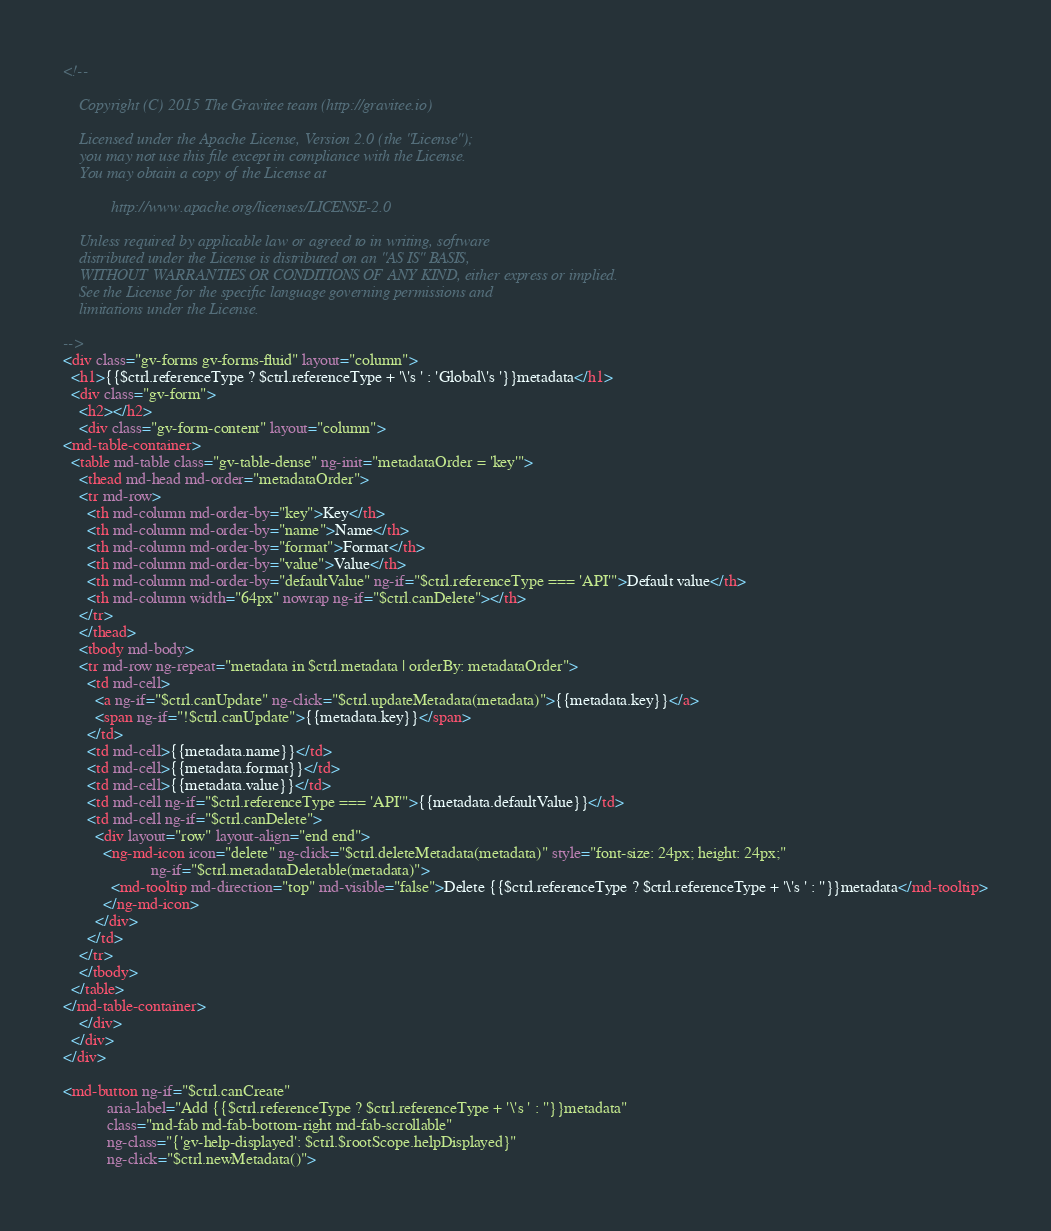<code> <loc_0><loc_0><loc_500><loc_500><_HTML_><!--

    Copyright (C) 2015 The Gravitee team (http://gravitee.io)

    Licensed under the Apache License, Version 2.0 (the "License");
    you may not use this file except in compliance with the License.
    You may obtain a copy of the License at

            http://www.apache.org/licenses/LICENSE-2.0

    Unless required by applicable law or agreed to in writing, software
    distributed under the License is distributed on an "AS IS" BASIS,
    WITHOUT WARRANTIES OR CONDITIONS OF ANY KIND, either express or implied.
    See the License for the specific language governing permissions and
    limitations under the License.

-->
<div class="gv-forms gv-forms-fluid" layout="column">
  <h1>{{$ctrl.referenceType ? $ctrl.referenceType + '\'s ' : 'Global\'s '}}metadata</h1>
  <div class="gv-form">
    <h2></h2>
    <div class="gv-form-content" layout="column">
<md-table-container>
  <table md-table class="gv-table-dense" ng-init="metadataOrder = 'key'">
    <thead md-head md-order="metadataOrder">
    <tr md-row>
      <th md-column md-order-by="key">Key</th>
      <th md-column md-order-by="name">Name</th>
      <th md-column md-order-by="format">Format</th>
      <th md-column md-order-by="value">Value</th>
      <th md-column md-order-by="defaultValue" ng-if="$ctrl.referenceType === 'API'">Default value</th>
      <th md-column width="64px" nowrap ng-if="$ctrl.canDelete"></th>
    </tr>
    </thead>
    <tbody md-body>
    <tr md-row ng-repeat="metadata in $ctrl.metadata | orderBy: metadataOrder">
      <td md-cell>
        <a ng-if="$ctrl.canUpdate" ng-click="$ctrl.updateMetadata(metadata)">{{metadata.key}}</a>
        <span ng-if="!$ctrl.canUpdate">{{metadata.key}}</span>
      </td>
      <td md-cell>{{metadata.name}}</td>
      <td md-cell>{{metadata.format}}</td>
      <td md-cell>{{metadata.value}}</td>
      <td md-cell ng-if="$ctrl.referenceType === 'API'">{{metadata.defaultValue}}</td>
      <td md-cell ng-if="$ctrl.canDelete">
        <div layout="row" layout-align="end end">
          <ng-md-icon icon="delete" ng-click="$ctrl.deleteMetadata(metadata)" style="font-size: 24px; height: 24px;"
                      ng-if="$ctrl.metadataDeletable(metadata)">
            <md-tooltip md-direction="top" md-visible="false">Delete {{$ctrl.referenceType ? $ctrl.referenceType + '\'s ' : ''}}metadata</md-tooltip>
          </ng-md-icon>
        </div>
      </td>
    </tr>
    </tbody>
  </table>
</md-table-container>
    </div>
  </div>
</div>

<md-button ng-if="$ctrl.canCreate"
           aria-label="Add {{$ctrl.referenceType ? $ctrl.referenceType + '\'s ' : ''}}metadata"
           class="md-fab md-fab-bottom-right md-fab-scrollable"
           ng-class="{'gv-help-displayed': $ctrl.$rootScope.helpDisplayed}"
           ng-click="$ctrl.newMetadata()"></code> 